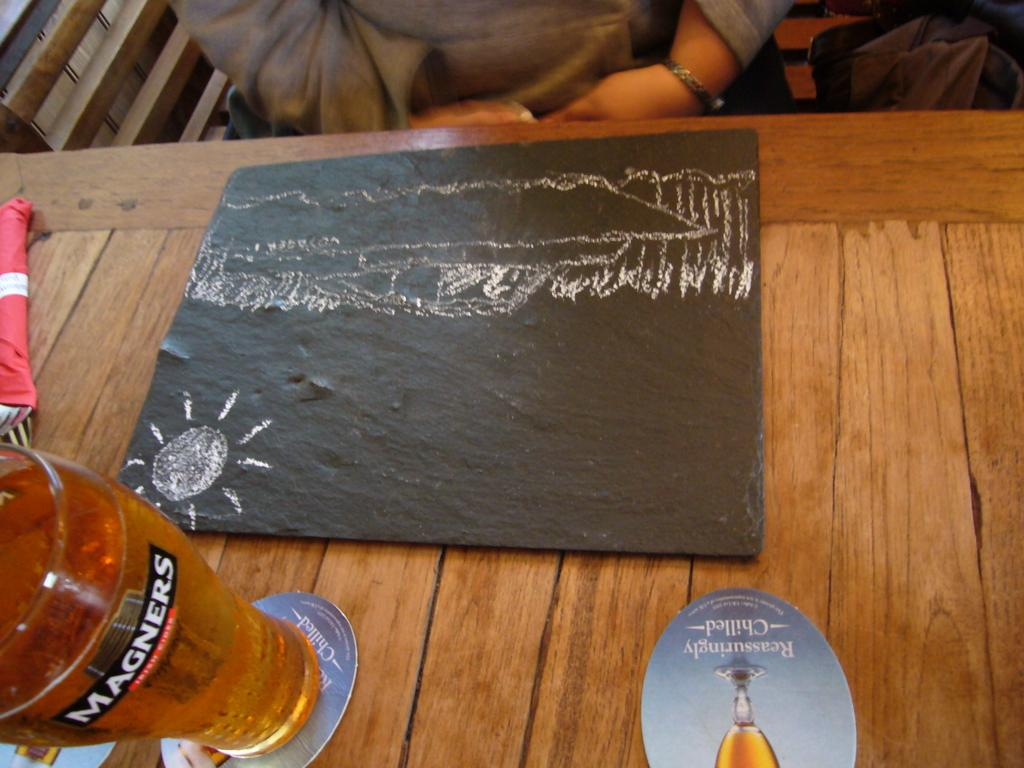<image>
Provide a brief description of the given image. A person is sitting at a restaurant table with a Magners beer. 